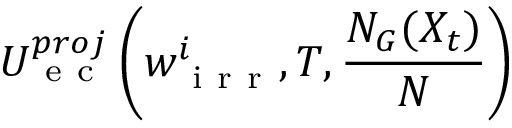Convert formula to latex. <formula><loc_0><loc_0><loc_500><loc_500>U _ { e c } ^ { p r o j } \left ( w _ { i r r } ^ { i } , T , \frac { N _ { G } ( X _ { t } ) } { N } \right )</formula> 